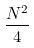<formula> <loc_0><loc_0><loc_500><loc_500>\frac { N ^ { 2 } } { 4 }</formula> 